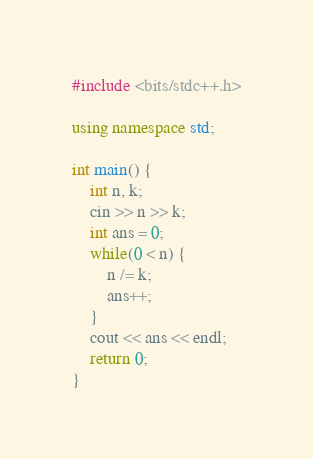Convert code to text. <code><loc_0><loc_0><loc_500><loc_500><_C++_>#include <bits/stdc++.h>

using namespace std;

int main() {
    int n, k;
    cin >> n >> k;
    int ans = 0;
    while(0 < n) {
        n /= k;
        ans++;
    }
    cout << ans << endl;
    return 0;
}</code> 